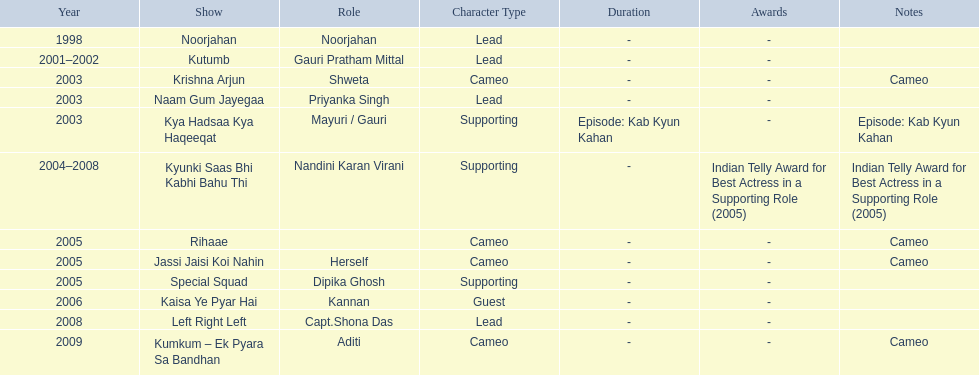On what shows did gauri pradhan tejwani appear after 2000? Kutumb, Krishna Arjun, Naam Gum Jayegaa, Kya Hadsaa Kya Haqeeqat, Kyunki Saas Bhi Kabhi Bahu Thi, Rihaae, Jassi Jaisi Koi Nahin, Special Squad, Kaisa Ye Pyar Hai, Left Right Left, Kumkum – Ek Pyara Sa Bandhan. In which of them was is a cameo appearance? Krishna Arjun, Rihaae, Jassi Jaisi Koi Nahin, Kumkum – Ek Pyara Sa Bandhan. Of these which one did she play the role of herself? Jassi Jaisi Koi Nahin. 